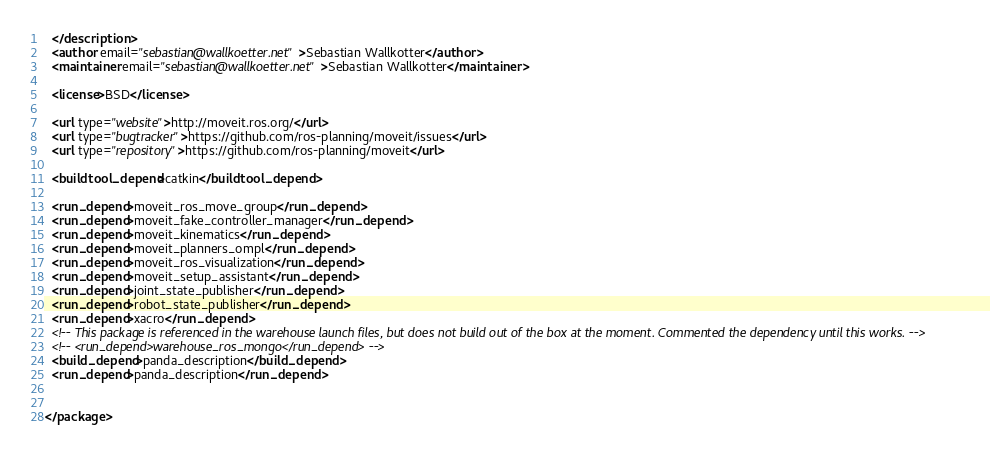<code> <loc_0><loc_0><loc_500><loc_500><_XML_>  </description>
  <author email="sebastian@wallkoetter.net">Sebastian Wallkotter</author>
  <maintainer email="sebastian@wallkoetter.net">Sebastian Wallkotter</maintainer>

  <license>BSD</license>

  <url type="website">http://moveit.ros.org/</url>
  <url type="bugtracker">https://github.com/ros-planning/moveit/issues</url>
  <url type="repository">https://github.com/ros-planning/moveit</url>

  <buildtool_depend>catkin</buildtool_depend>

  <run_depend>moveit_ros_move_group</run_depend>
  <run_depend>moveit_fake_controller_manager</run_depend>
  <run_depend>moveit_kinematics</run_depend>
  <run_depend>moveit_planners_ompl</run_depend>
  <run_depend>moveit_ros_visualization</run_depend>
  <run_depend>moveit_setup_assistant</run_depend>
  <run_depend>joint_state_publisher</run_depend>
  <run_depend>robot_state_publisher</run_depend>
  <run_depend>xacro</run_depend>
  <!-- This package is referenced in the warehouse launch files, but does not build out of the box at the moment. Commented the dependency until this works. -->
  <!-- <run_depend>warehouse_ros_mongo</run_depend> -->
  <build_depend>panda_description</build_depend>
  <run_depend>panda_description</run_depend>


</package>
</code> 